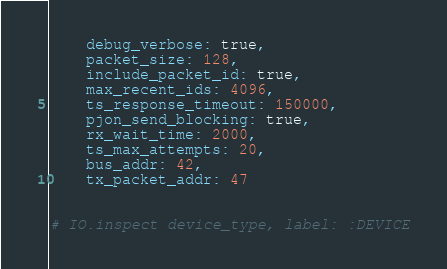<code> <loc_0><loc_0><loc_500><loc_500><_Elixir_>    debug_verbose: true,
    packet_size: 128,
    include_packet_id: true,
    max_recent_ids: 4096,
    ts_response_timeout: 150000,
    pjon_send_blocking: true,
    rx_wait_time: 2000,
    ts_max_attempts: 20,
    bus_addr: 42,
    tx_packet_addr: 47


# IO.inspect device_type, label: :DEVICE

</code> 